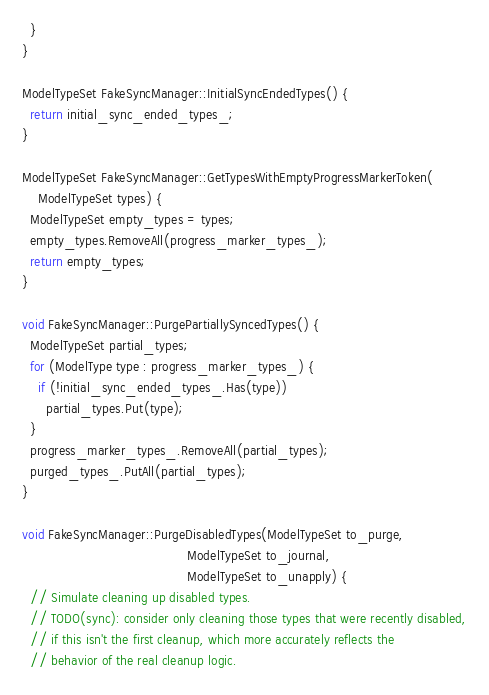<code> <loc_0><loc_0><loc_500><loc_500><_C++_>  }
}

ModelTypeSet FakeSyncManager::InitialSyncEndedTypes() {
  return initial_sync_ended_types_;
}

ModelTypeSet FakeSyncManager::GetTypesWithEmptyProgressMarkerToken(
    ModelTypeSet types) {
  ModelTypeSet empty_types = types;
  empty_types.RemoveAll(progress_marker_types_);
  return empty_types;
}

void FakeSyncManager::PurgePartiallySyncedTypes() {
  ModelTypeSet partial_types;
  for (ModelType type : progress_marker_types_) {
    if (!initial_sync_ended_types_.Has(type))
      partial_types.Put(type);
  }
  progress_marker_types_.RemoveAll(partial_types);
  purged_types_.PutAll(partial_types);
}

void FakeSyncManager::PurgeDisabledTypes(ModelTypeSet to_purge,
                                         ModelTypeSet to_journal,
                                         ModelTypeSet to_unapply) {
  // Simulate cleaning up disabled types.
  // TODO(sync): consider only cleaning those types that were recently disabled,
  // if this isn't the first cleanup, which more accurately reflects the
  // behavior of the real cleanup logic.</code> 